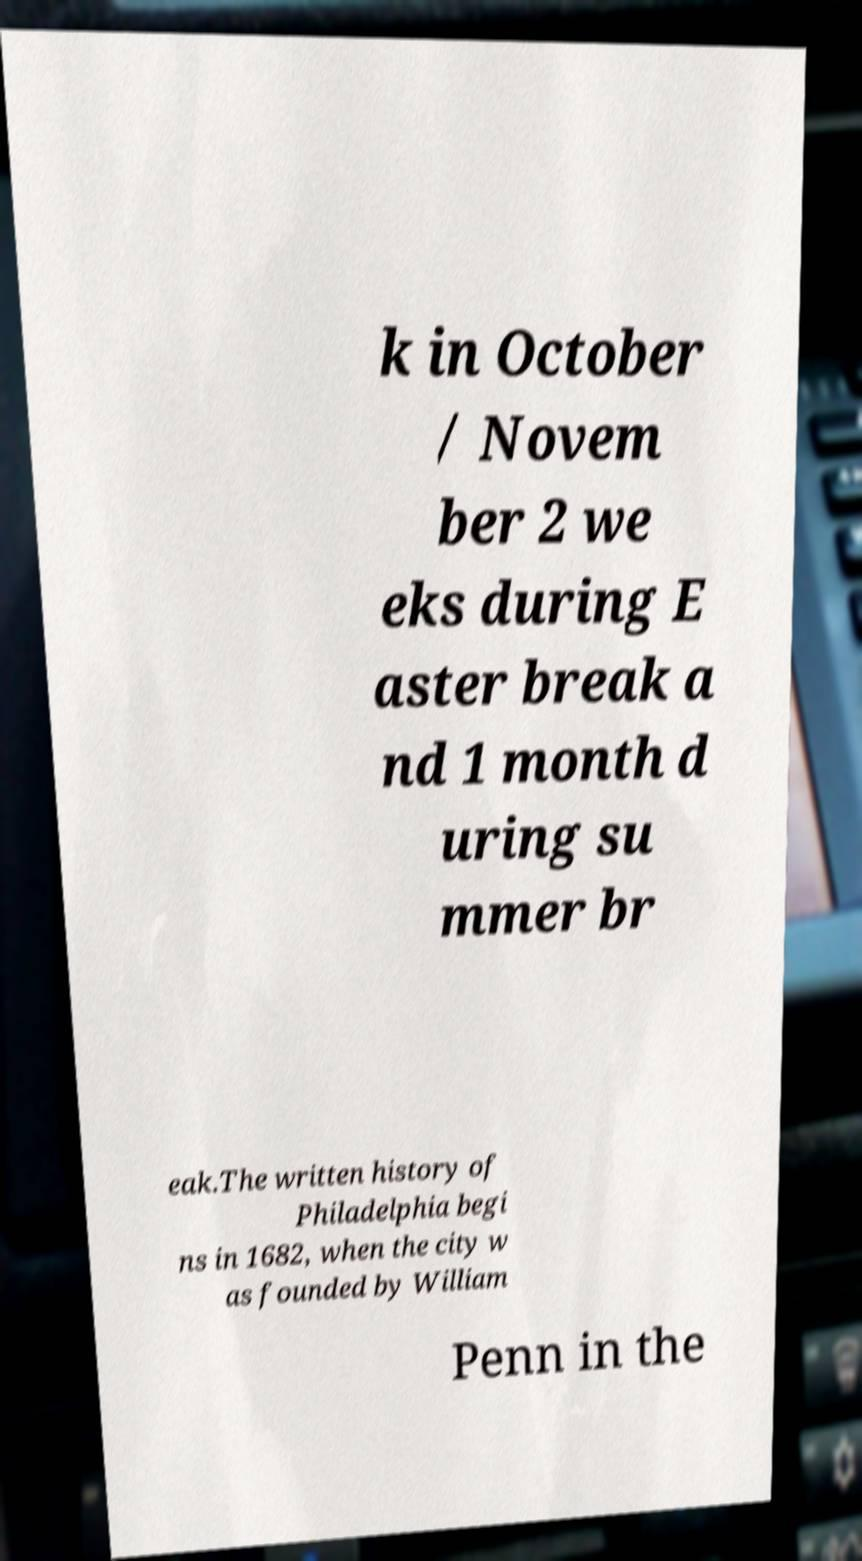Please read and relay the text visible in this image. What does it say? k in October / Novem ber 2 we eks during E aster break a nd 1 month d uring su mmer br eak.The written history of Philadelphia begi ns in 1682, when the city w as founded by William Penn in the 